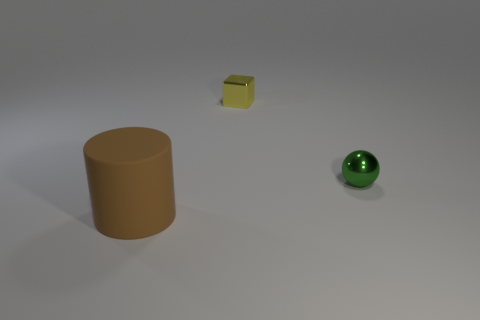Add 3 big brown metal cubes. How many objects exist? 6 Subtract all blocks. How many objects are left? 2 Subtract all large things. Subtract all brown things. How many objects are left? 1 Add 3 brown things. How many brown things are left? 4 Add 1 green metallic spheres. How many green metallic spheres exist? 2 Subtract 0 cyan blocks. How many objects are left? 3 